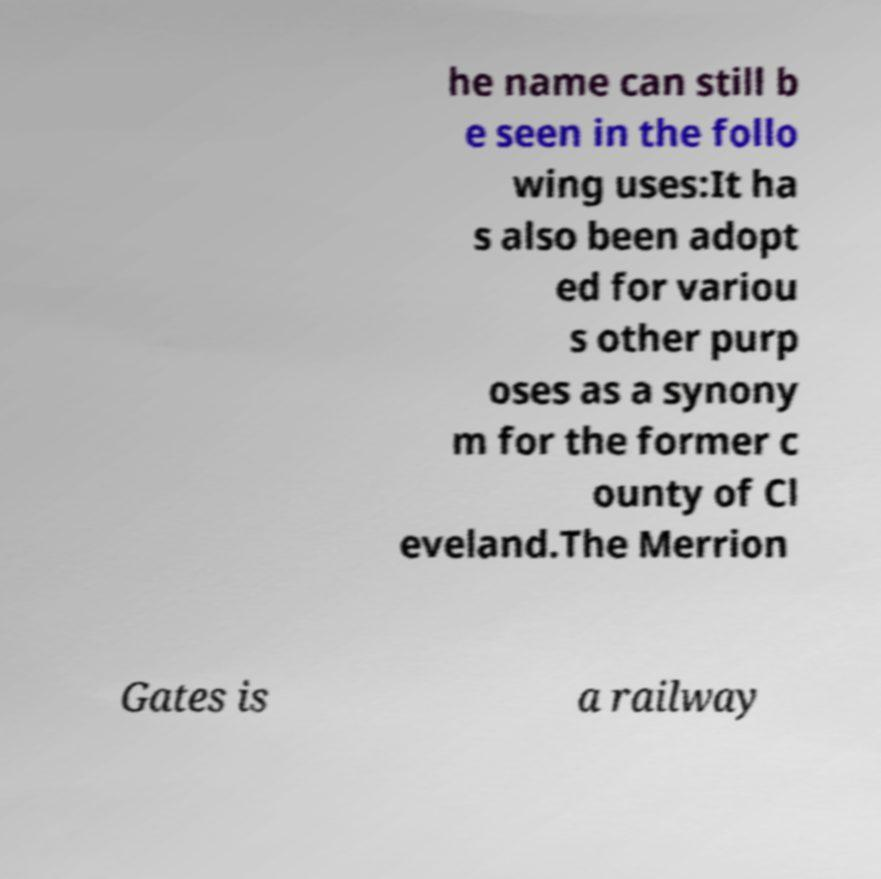Could you assist in decoding the text presented in this image and type it out clearly? he name can still b e seen in the follo wing uses:It ha s also been adopt ed for variou s other purp oses as a synony m for the former c ounty of Cl eveland.The Merrion Gates is a railway 